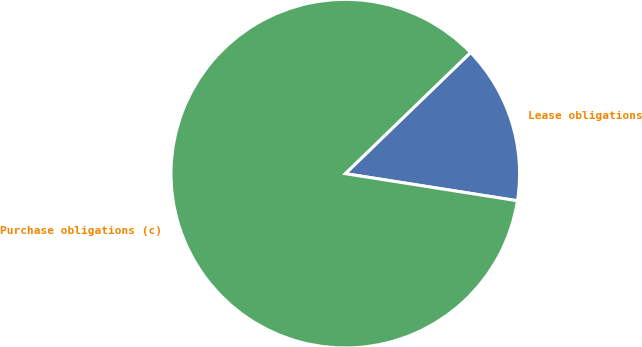Convert chart to OTSL. <chart><loc_0><loc_0><loc_500><loc_500><pie_chart><fcel>Lease obligations<fcel>Purchase obligations (c)<nl><fcel>14.72%<fcel>85.28%<nl></chart> 